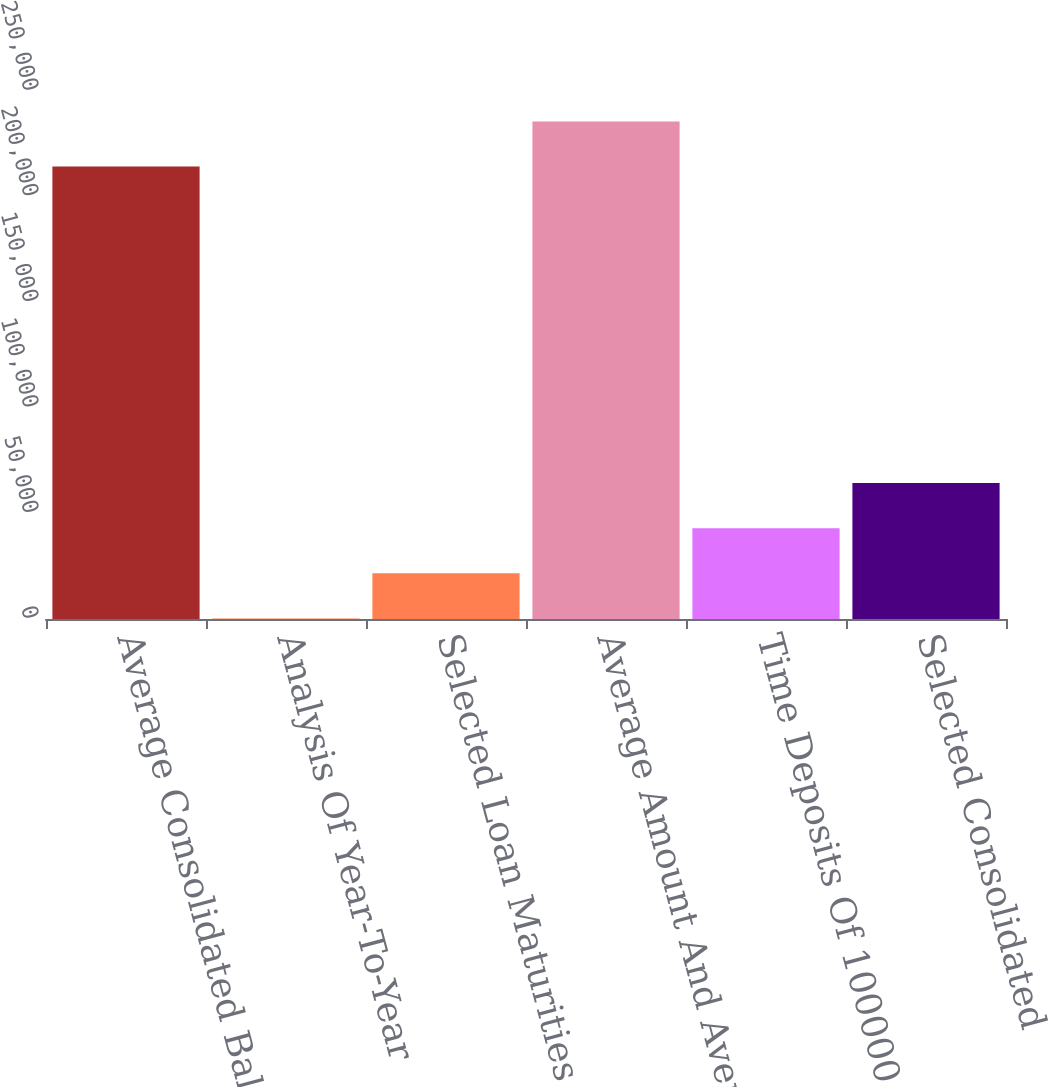Convert chart. <chart><loc_0><loc_0><loc_500><loc_500><bar_chart><fcel>Average Consolidated Balance<fcel>Analysis Of Year-To-Year<fcel>Selected Loan Maturities And<fcel>Average Amount And Average<fcel>Time Deposits Of 100000 Or<fcel>Selected Consolidated<nl><fcel>214215<fcel>216<fcel>21615.9<fcel>235615<fcel>43015.8<fcel>64415.7<nl></chart> 